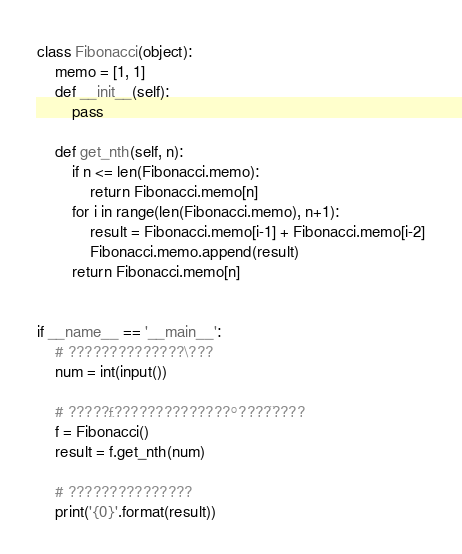Convert code to text. <code><loc_0><loc_0><loc_500><loc_500><_Python_>class Fibonacci(object):
    memo = [1, 1]
    def __init__(self):
        pass

    def get_nth(self, n):
        if n <= len(Fibonacci.memo):
            return Fibonacci.memo[n]
        for i in range(len(Fibonacci.memo), n+1):
            result = Fibonacci.memo[i-1] + Fibonacci.memo[i-2]
            Fibonacci.memo.append(result)
        return Fibonacci.memo[n]


if __name__ == '__main__':
    # ??????????????\???
    num = int(input())

    # ?????£??????????????°????¨????
    f = Fibonacci()
    result = f.get_nth(num)

    # ???????????????
    print('{0}'.format(result))</code> 